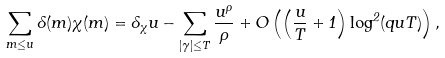<formula> <loc_0><loc_0><loc_500><loc_500>\sum _ { m \leq u } \Lambda ( m ) \chi ( m ) = \delta _ { \chi } u - \sum _ { | \gamma | \leq T } \frac { u ^ { \rho } } { \rho } + O \left ( \left ( \frac { u } { T } + 1 \right ) \log ^ { 2 } ( q u T ) \right ) ,</formula> 